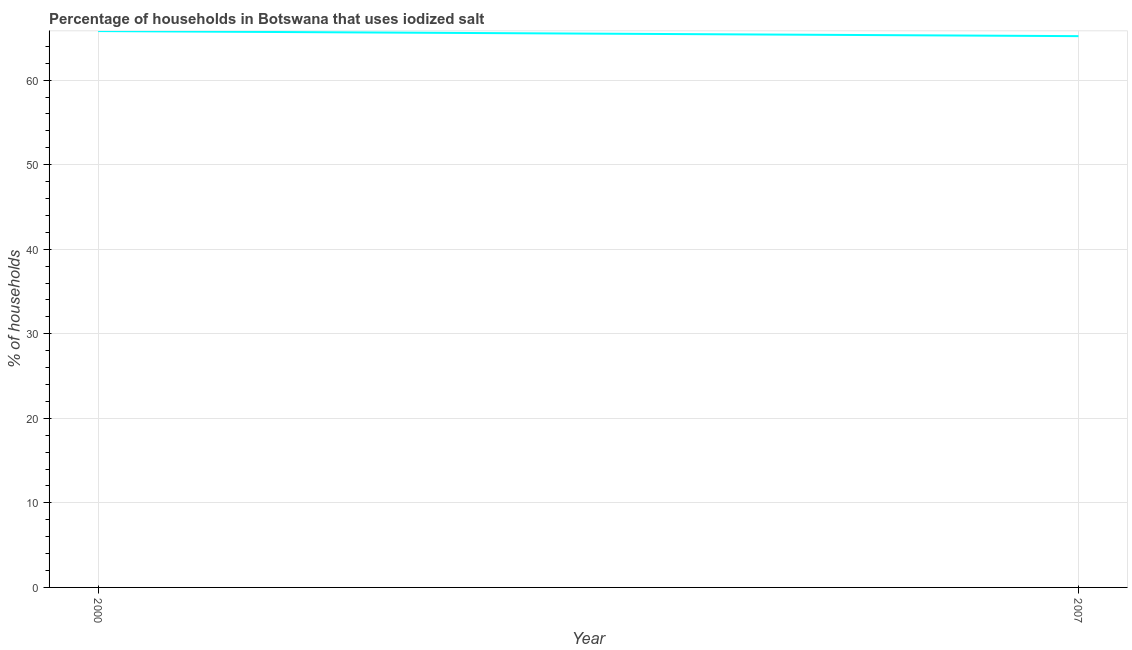What is the percentage of households where iodized salt is consumed in 2007?
Your answer should be very brief. 65.2. Across all years, what is the maximum percentage of households where iodized salt is consumed?
Offer a terse response. 65.8. Across all years, what is the minimum percentage of households where iodized salt is consumed?
Offer a very short reply. 65.2. In which year was the percentage of households where iodized salt is consumed minimum?
Your answer should be very brief. 2007. What is the sum of the percentage of households where iodized salt is consumed?
Keep it short and to the point. 131. What is the difference between the percentage of households where iodized salt is consumed in 2000 and 2007?
Your answer should be very brief. 0.6. What is the average percentage of households where iodized salt is consumed per year?
Your answer should be compact. 65.5. What is the median percentage of households where iodized salt is consumed?
Make the answer very short. 65.5. What is the ratio of the percentage of households where iodized salt is consumed in 2000 to that in 2007?
Offer a very short reply. 1.01. Does the percentage of households where iodized salt is consumed monotonically increase over the years?
Provide a short and direct response. No. How many years are there in the graph?
Your answer should be compact. 2. Does the graph contain any zero values?
Keep it short and to the point. No. Does the graph contain grids?
Provide a succinct answer. Yes. What is the title of the graph?
Your answer should be very brief. Percentage of households in Botswana that uses iodized salt. What is the label or title of the Y-axis?
Offer a very short reply. % of households. What is the % of households in 2000?
Make the answer very short. 65.8. What is the % of households of 2007?
Provide a succinct answer. 65.2. What is the difference between the % of households in 2000 and 2007?
Ensure brevity in your answer.  0.6. What is the ratio of the % of households in 2000 to that in 2007?
Offer a very short reply. 1.01. 